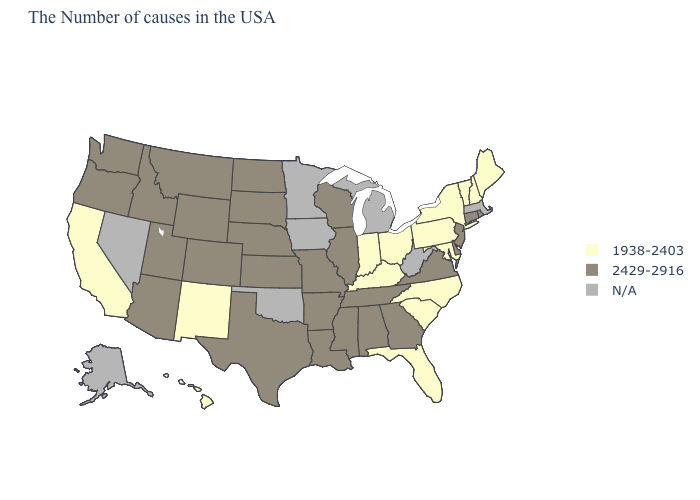Does New Hampshire have the highest value in the USA?
Quick response, please. No. What is the value of Nevada?
Be succinct. N/A. What is the value of Hawaii?
Concise answer only. 1938-2403. Name the states that have a value in the range 2429-2916?
Keep it brief. Rhode Island, Connecticut, New Jersey, Delaware, Virginia, Georgia, Alabama, Tennessee, Wisconsin, Illinois, Mississippi, Louisiana, Missouri, Arkansas, Kansas, Nebraska, Texas, South Dakota, North Dakota, Wyoming, Colorado, Utah, Montana, Arizona, Idaho, Washington, Oregon. Which states have the highest value in the USA?
Give a very brief answer. Rhode Island, Connecticut, New Jersey, Delaware, Virginia, Georgia, Alabama, Tennessee, Wisconsin, Illinois, Mississippi, Louisiana, Missouri, Arkansas, Kansas, Nebraska, Texas, South Dakota, North Dakota, Wyoming, Colorado, Utah, Montana, Arizona, Idaho, Washington, Oregon. Does Rhode Island have the highest value in the Northeast?
Be succinct. Yes. Name the states that have a value in the range 1938-2403?
Write a very short answer. Maine, New Hampshire, Vermont, New York, Maryland, Pennsylvania, North Carolina, South Carolina, Ohio, Florida, Kentucky, Indiana, New Mexico, California, Hawaii. Name the states that have a value in the range N/A?
Give a very brief answer. Massachusetts, West Virginia, Michigan, Minnesota, Iowa, Oklahoma, Nevada, Alaska. What is the highest value in the USA?
Be succinct. 2429-2916. What is the value of Vermont?
Short answer required. 1938-2403. Does the map have missing data?
Short answer required. Yes. Name the states that have a value in the range N/A?
Be succinct. Massachusetts, West Virginia, Michigan, Minnesota, Iowa, Oklahoma, Nevada, Alaska. Does Colorado have the lowest value in the USA?
Keep it brief. No. 